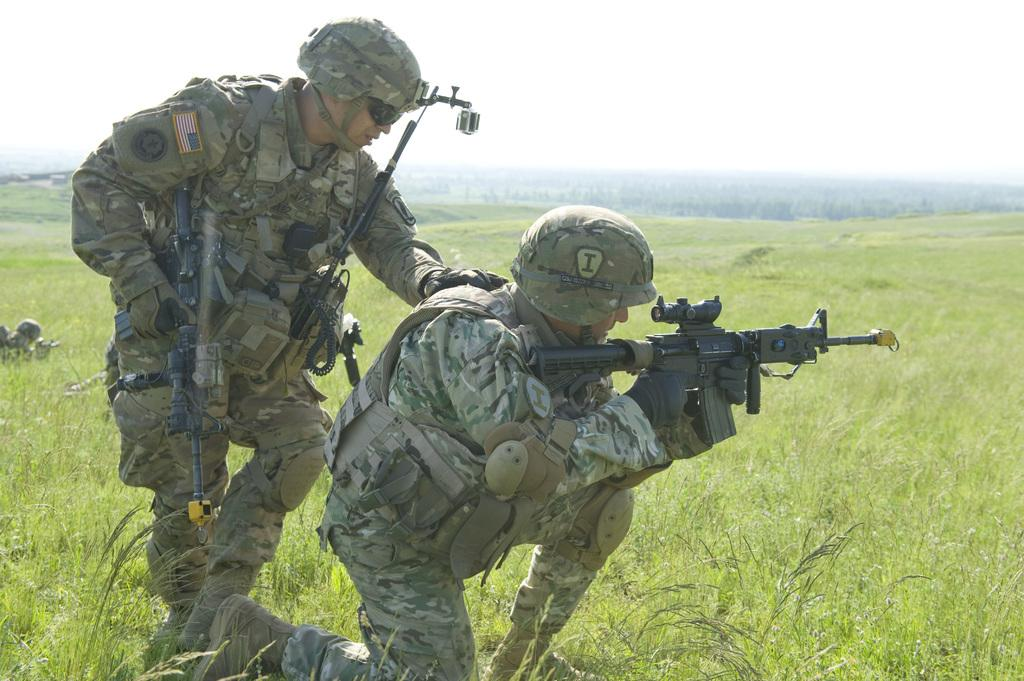What are the people in the image wearing? The people in the image are wearing uniforms. What are the people holding in the image? The people are holding guns. What type of terrain is visible in the image? The ground is covered with grass. What is visible in the background of the image? The sky is visible in the background of the image. What type of creature is present in the image? There is no creature present in the image. 